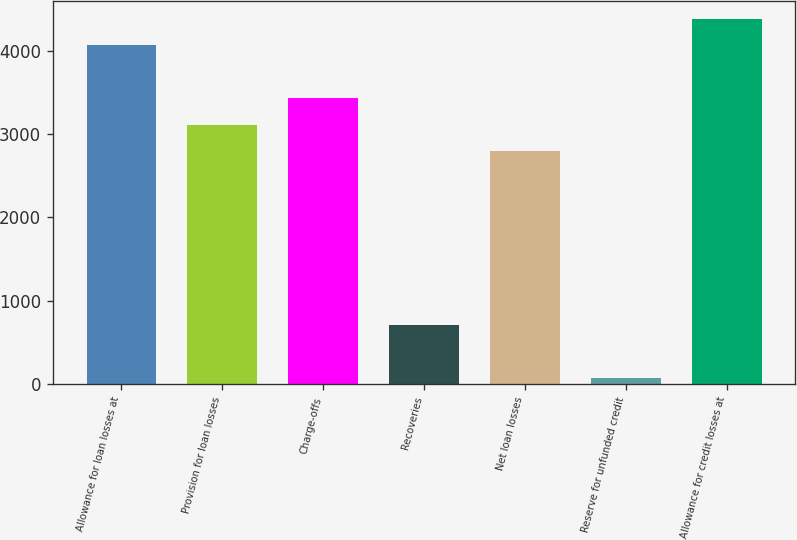<chart> <loc_0><loc_0><loc_500><loc_500><bar_chart><fcel>Allowance for loan losses at<fcel>Provision for loan losses<fcel>Charge-offs<fcel>Recoveries<fcel>Net loan losses<fcel>Reserve for unfunded credit<fcel>Allowance for credit losses at<nl><fcel>4066<fcel>3110.5<fcel>3429<fcel>708<fcel>2792<fcel>71<fcel>4384.5<nl></chart> 